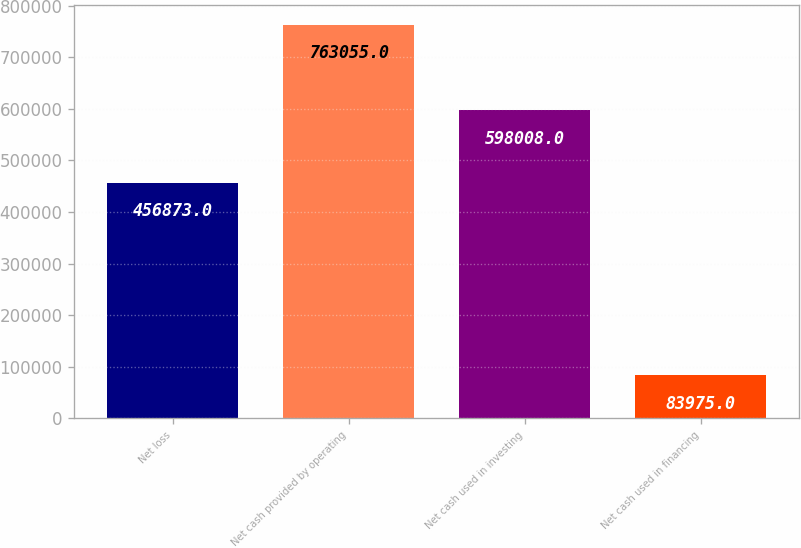Convert chart to OTSL. <chart><loc_0><loc_0><loc_500><loc_500><bar_chart><fcel>Net loss<fcel>Net cash provided by operating<fcel>Net cash used in investing<fcel>Net cash used in financing<nl><fcel>456873<fcel>763055<fcel>598008<fcel>83975<nl></chart> 